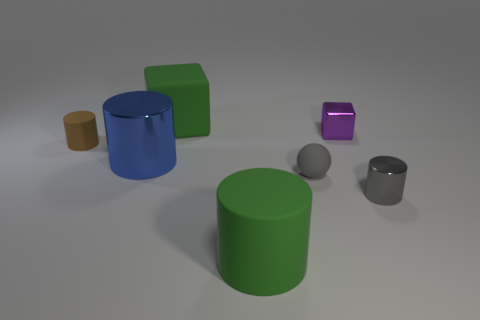Does the purple thing have the same shape as the gray metallic thing?
Provide a short and direct response. No. Is there anything else that has the same size as the purple cube?
Ensure brevity in your answer.  Yes. There is a small purple object; what number of big green cylinders are behind it?
Make the answer very short. 0. Is the size of the green thing in front of the brown rubber cylinder the same as the big green block?
Give a very brief answer. Yes. There is another large object that is the same shape as the big blue metal thing; what is its color?
Your answer should be very brief. Green. Is there any other thing that is the same shape as the blue metal object?
Ensure brevity in your answer.  Yes. What shape is the tiny gray object to the left of the gray metal cylinder?
Provide a succinct answer. Sphere. What number of green rubber things are the same shape as the brown matte object?
Your answer should be very brief. 1. There is a cylinder that is to the left of the blue object; is its color the same as the cube that is behind the purple cube?
Ensure brevity in your answer.  No. What number of things are large purple metal blocks or small gray objects?
Provide a succinct answer. 2. 